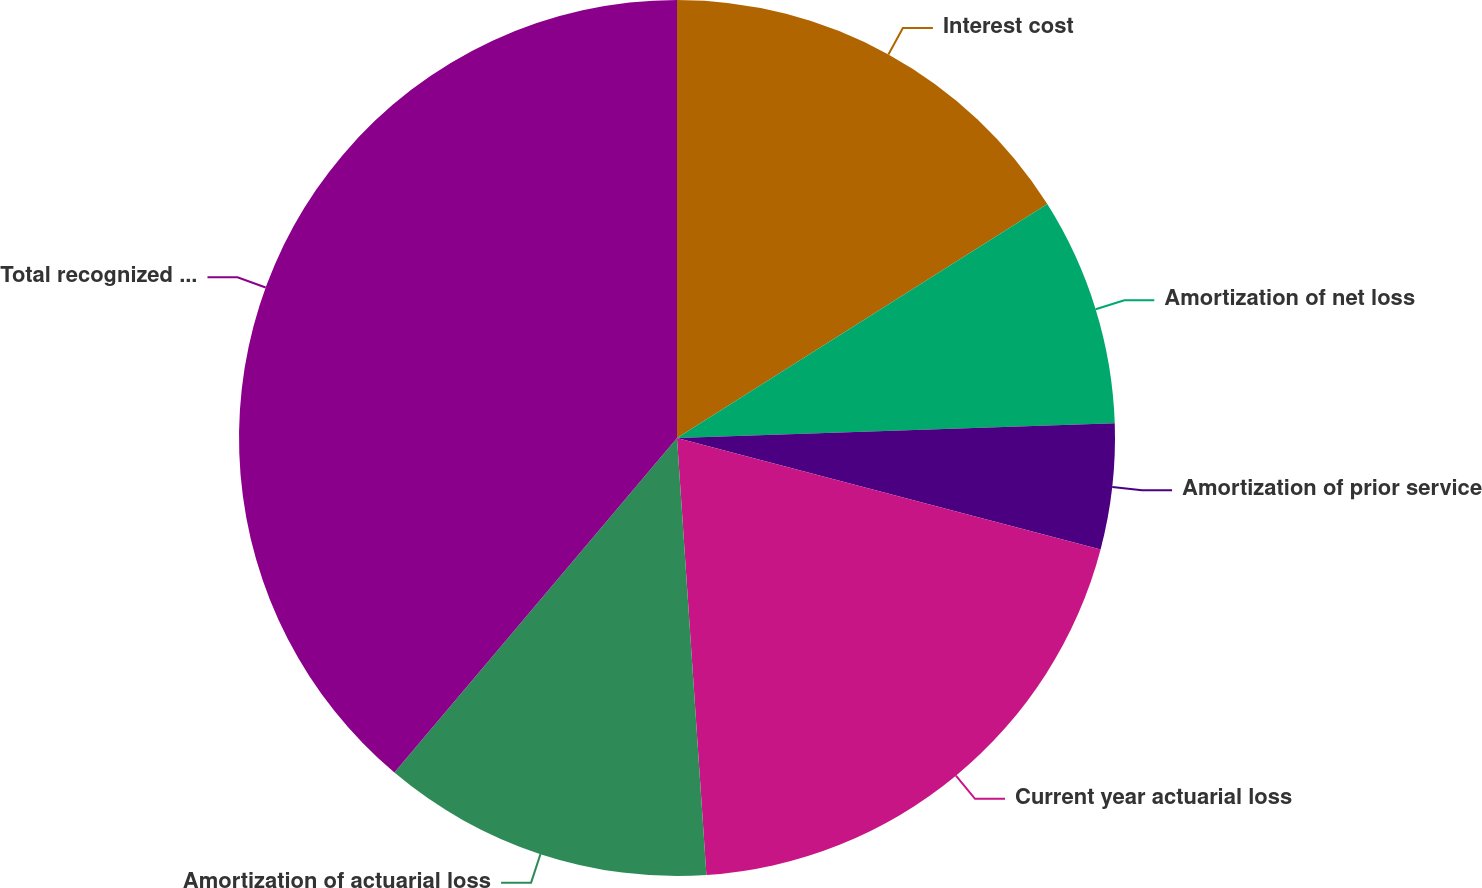Convert chart to OTSL. <chart><loc_0><loc_0><loc_500><loc_500><pie_chart><fcel>Interest cost<fcel>Amortization of net loss<fcel>Amortization of prior service<fcel>Current year actuarial loss<fcel>Amortization of actuarial loss<fcel>Total recognized in net<nl><fcel>16.03%<fcel>8.43%<fcel>4.63%<fcel>19.83%<fcel>12.23%<fcel>38.83%<nl></chart> 